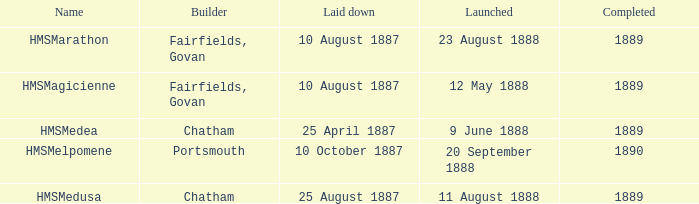Which constructor finished after 1889? Portsmouth. 